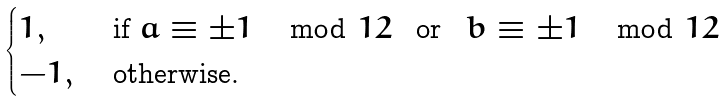Convert formula to latex. <formula><loc_0><loc_0><loc_500><loc_500>\begin{cases} 1 , & \text { if } a \equiv \pm 1 \mod 1 2 \text { \, or \, } b \equiv \pm 1 \mod 1 2 \\ - 1 , & \text { otherwise.} \end{cases}</formula> 